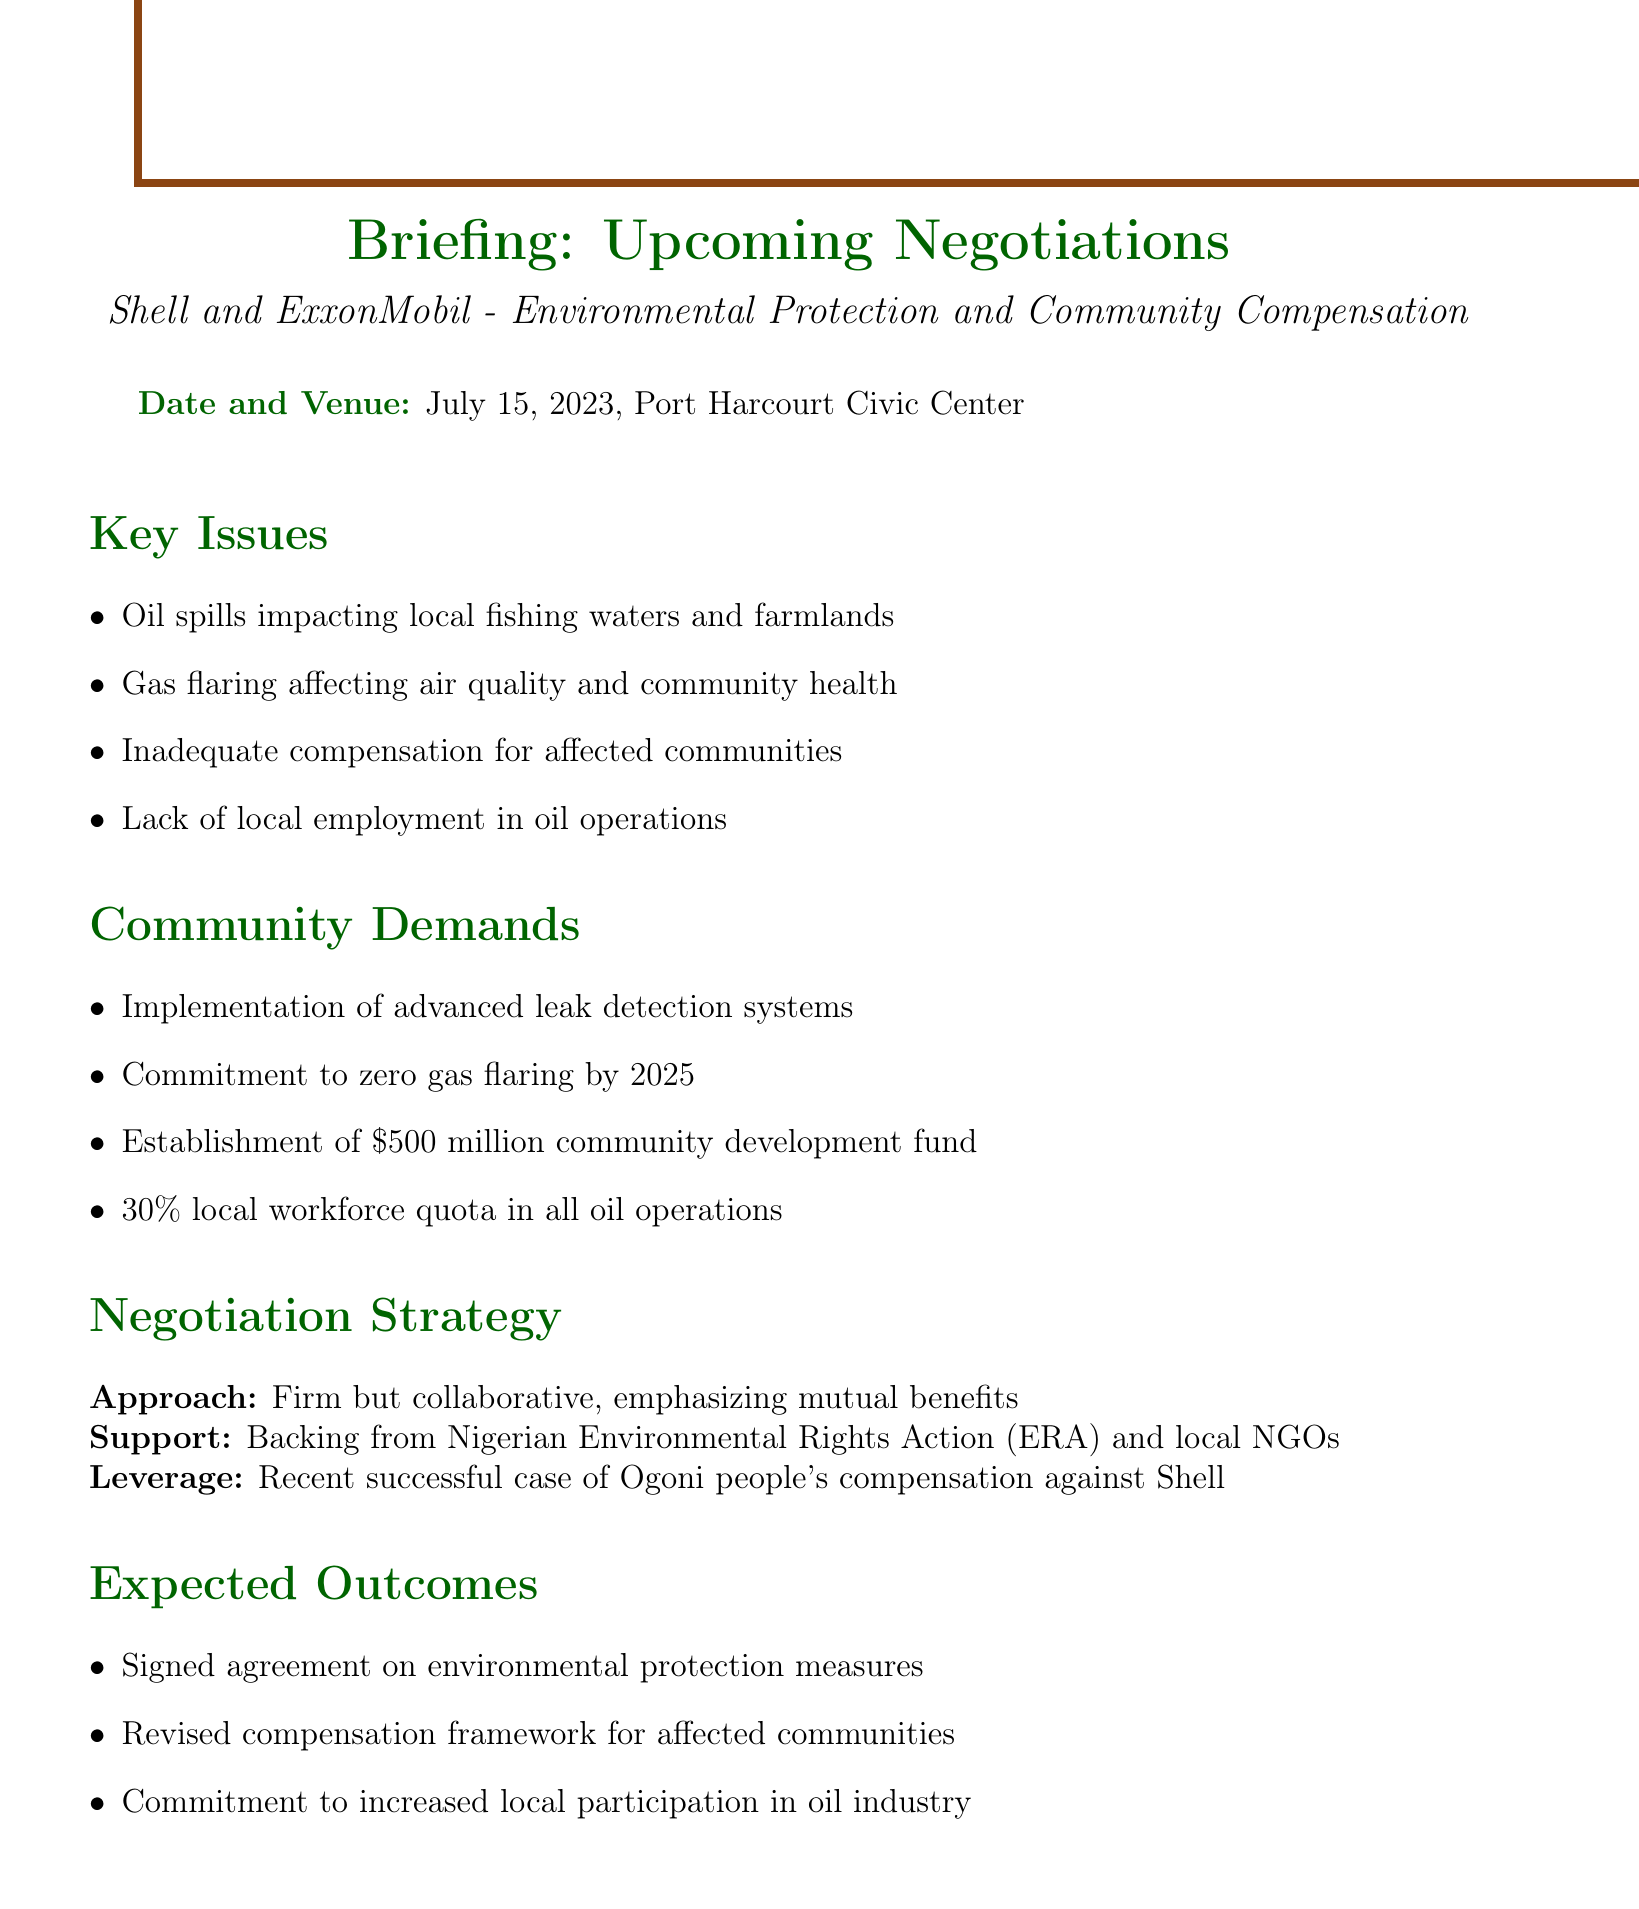What is the date of the upcoming negotiations? The date of the negotiations is specified in the document.
Answer: July 15, 2023 Where will the negotiations take place? The venue for the negotiations is mentioned in the document.
Answer: Port Harcourt Civic Center What is one key issue listed regarding oil operations? Key issues related to oil operations that affect the community are highlighted.
Answer: Oil spills impacting local fishing waters and farmlands What is one demand from the community? The community demands specific actions from the oil companies, which are listed in the document.
Answer: Commitment to zero gas flaring by 2025 What is the negotiation strategy's approach? The document describes the approach to negotiations in detail.
Answer: Firm but collaborative What is the expected outcome regarding community participation? The document outlines expected commitments from the oil companies.
Answer: Commitment to increased local participation in oil industry How much is the proposed community development fund? The document specifies the financial demand from the community for development.
Answer: $500 million Who supports the negotiation efforts? The document mentions organizations that back the negotiation efforts.
Answer: Nigerian Environmental Rights Action (ERA) and local NGOs What follow-up action involves community engagement? Follow-up actions include measures for ongoing community involvement as outlined in the document.
Answer: Community briefing on negotiation results 